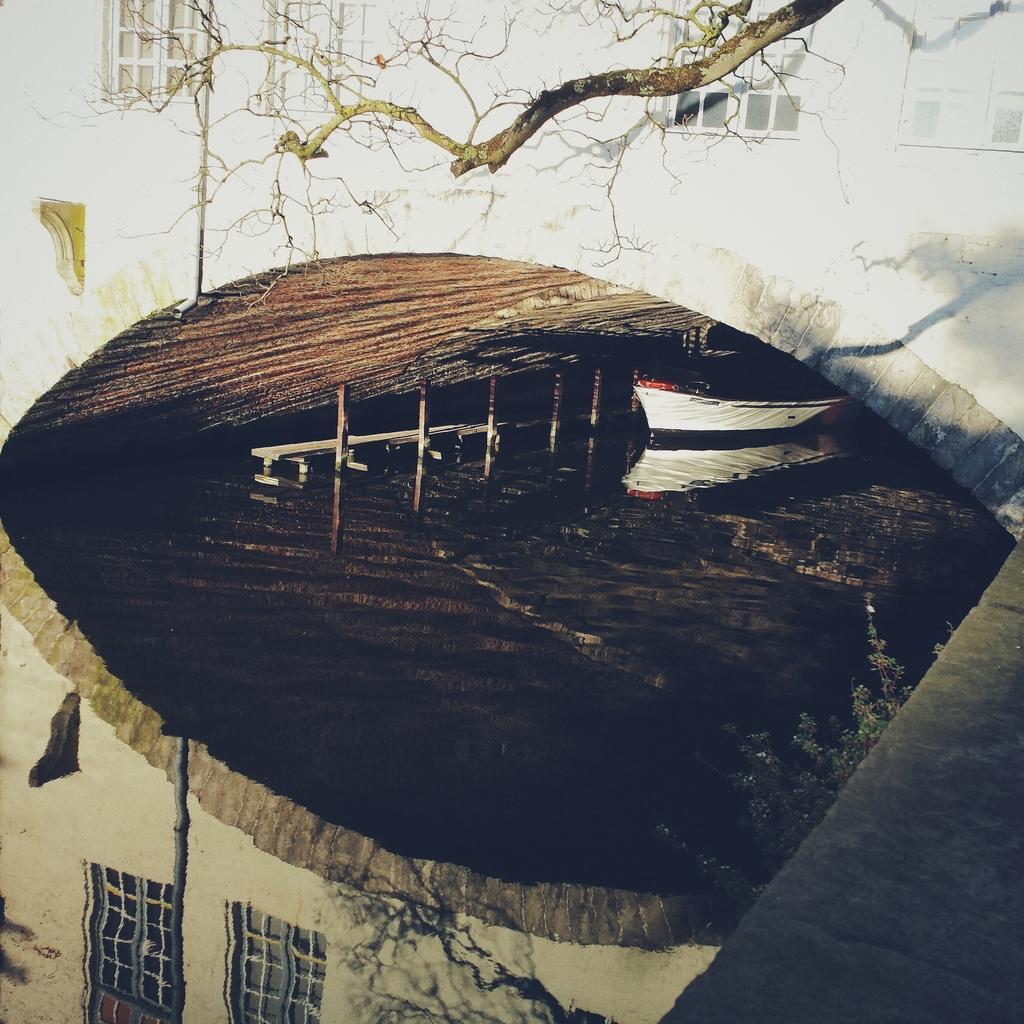Can you describe this image briefly? In this picture there is a boat on the water and there is a railing. At the top there is a building and there are windows and there is a tree and pole. At the bottom there is a reflection of a building, tree and pole on the water. On the right side of the image it looks like a wall. 